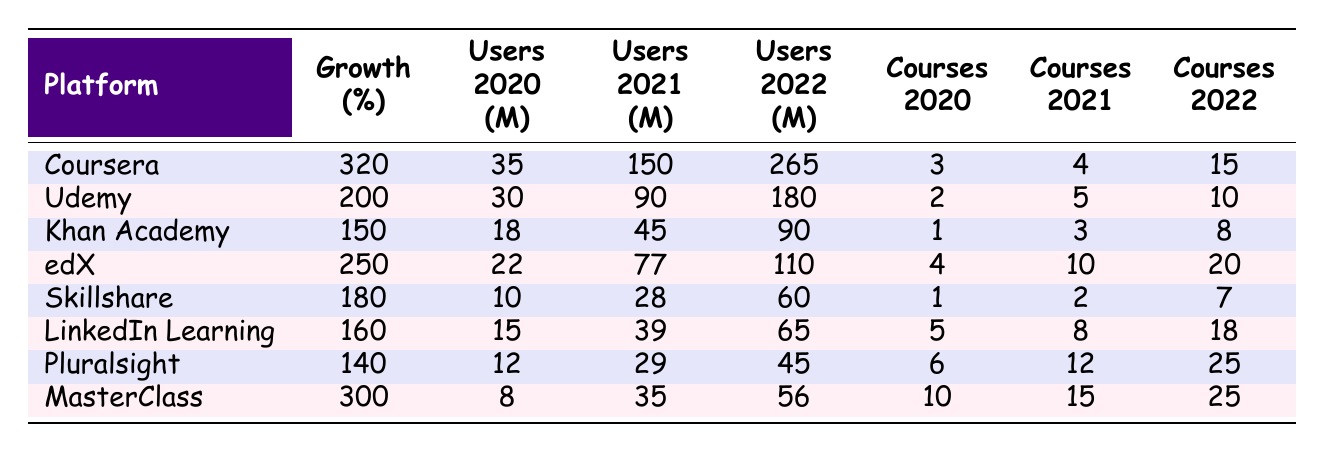What is the user growth percentage for Coursera? The table shows that Coursera has a user growth percentage of 320.
Answer: 320 Which platform had the highest number of total users in 2022? The platform with the highest total users in 2022 is Coursera, with 265 total users.
Answer: Coursera How many users did Udemy have in 2021? According to the table, Udemy had 90 users in 2021.
Answer: 90 What is the average number of courses offered across all platforms in 2022? We sum the courses offered in 2022: (15 + 10 + 8 + 20 + 7 + 18 + 25 + 25) = 128. There are 8 platforms, so the average is 128 / 8 = 16.
Answer: 16 Is it true that LinkedIn Learning had more courses offered in 2022 than Pluralsight? Yes, LinkedIn Learning offered 18 courses in 2022, while Pluralsight offered 25 courses, which is greater than 18.
Answer: No Which platform had the lowest user growth percentage? The table indicates that Pluralsight had the lowest user growth percentage at 140.
Answer: Pluralsight What was the difference in total users between Khan Academy in 2022 and 2020? Khan Academy had 90 total users in 2022 and 18 total users in 2020. The difference is 90 - 18 = 72.
Answer: 72 Did MasterClass have more courses in 2021 than Coursera? Yes, MasterClass had 15 courses in 2021, while Coursera had 4 courses.
Answer: Yes What is the total number of users for all platforms combined in 2021? We calculate the total users in 2021: 150 + 90 + 45 + 77 + 28 + 39 + 29 + 35 = 493.
Answer: 493 